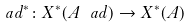<formula> <loc_0><loc_0><loc_500><loc_500>\ a d ^ { * } \colon X ^ { * } ( { A } ^ { \ } a d ) \rightarrow X ^ { * } ( { A } )</formula> 